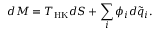Convert formula to latex. <formula><loc_0><loc_0><loc_500><loc_500>d M = T _ { H K } d S + \sum _ { i } \phi _ { i } d \tilde { q } _ { i } .</formula> 